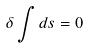Convert formula to latex. <formula><loc_0><loc_0><loc_500><loc_500>\delta \int d s = 0</formula> 